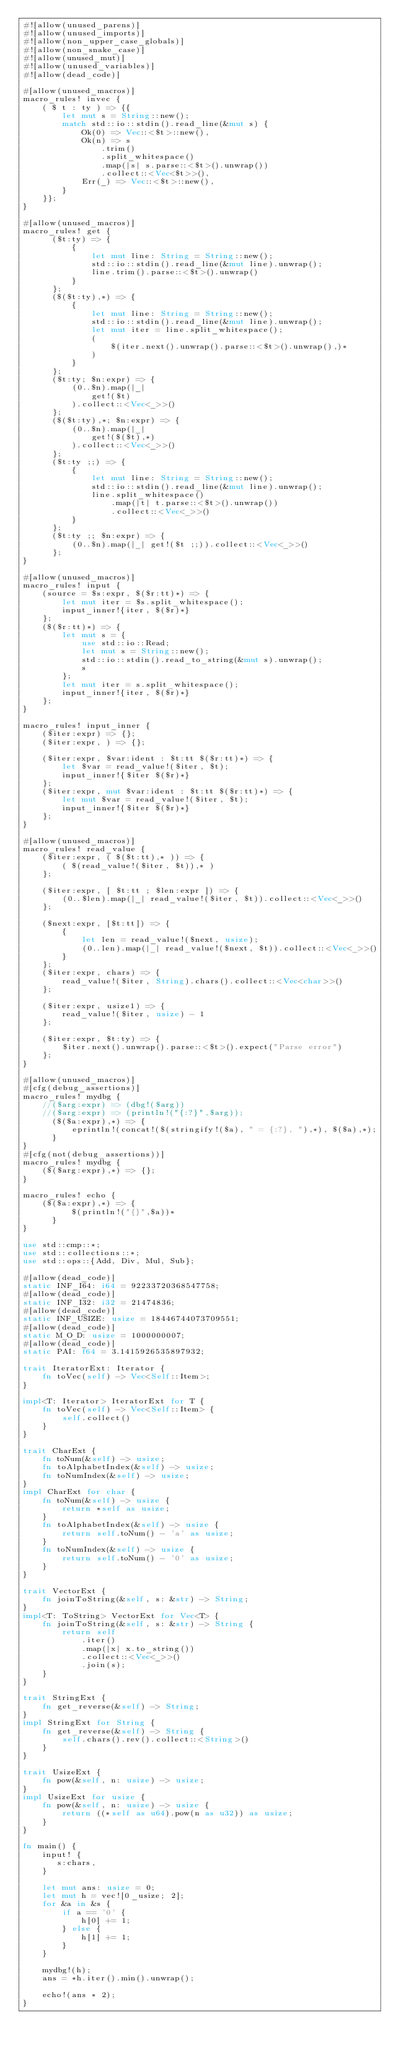Convert code to text. <code><loc_0><loc_0><loc_500><loc_500><_Rust_>#![allow(unused_parens)]
#![allow(unused_imports)]
#![allow(non_upper_case_globals)]
#![allow(non_snake_case)]
#![allow(unused_mut)]
#![allow(unused_variables)]
#![allow(dead_code)]

#[allow(unused_macros)]
macro_rules! invec {
    ( $ t : ty ) => {{
        let mut s = String::new();
        match std::io::stdin().read_line(&mut s) {
            Ok(0) => Vec::<$t>::new(),
            Ok(n) => s
                .trim()
                .split_whitespace()
                .map(|s| s.parse::<$t>().unwrap())
                .collect::<Vec<$t>>(),
            Err(_) => Vec::<$t>::new(),
        }
    }};
}

#[allow(unused_macros)]
macro_rules! get {
      ($t:ty) => {
          {
              let mut line: String = String::new();
              std::io::stdin().read_line(&mut line).unwrap();
              line.trim().parse::<$t>().unwrap()
          }
      };
      ($($t:ty),*) => {
          {
              let mut line: String = String::new();
              std::io::stdin().read_line(&mut line).unwrap();
              let mut iter = line.split_whitespace();
              (
                  $(iter.next().unwrap().parse::<$t>().unwrap(),)*
              )
          }
      };
      ($t:ty; $n:expr) => {
          (0..$n).map(|_|
              get!($t)
          ).collect::<Vec<_>>()
      };
      ($($t:ty),*; $n:expr) => {
          (0..$n).map(|_|
              get!($($t),*)
          ).collect::<Vec<_>>()
      };
      ($t:ty ;;) => {
          {
              let mut line: String = String::new();
              std::io::stdin().read_line(&mut line).unwrap();
              line.split_whitespace()
                  .map(|t| t.parse::<$t>().unwrap())
                  .collect::<Vec<_>>()
          }
      };
      ($t:ty ;; $n:expr) => {
          (0..$n).map(|_| get!($t ;;)).collect::<Vec<_>>()
      };
}

#[allow(unused_macros)]
macro_rules! input {
    (source = $s:expr, $($r:tt)*) => {
        let mut iter = $s.split_whitespace();
        input_inner!{iter, $($r)*}
    };
    ($($r:tt)*) => {
        let mut s = {
            use std::io::Read;
            let mut s = String::new();
            std::io::stdin().read_to_string(&mut s).unwrap();
            s
        };
        let mut iter = s.split_whitespace();
        input_inner!{iter, $($r)*}
    };
}

macro_rules! input_inner {
    ($iter:expr) => {};
    ($iter:expr, ) => {};

    ($iter:expr, $var:ident : $t:tt $($r:tt)*) => {
        let $var = read_value!($iter, $t);
        input_inner!{$iter $($r)*}
    };
    ($iter:expr, mut $var:ident : $t:tt $($r:tt)*) => {
        let mut $var = read_value!($iter, $t);
        input_inner!{$iter $($r)*}
    };
}

#[allow(unused_macros)]
macro_rules! read_value {
    ($iter:expr, ( $($t:tt),* )) => {
        ( $(read_value!($iter, $t)),* )
    };

    ($iter:expr, [ $t:tt ; $len:expr ]) => {
        (0..$len).map(|_| read_value!($iter, $t)).collect::<Vec<_>>()
    };

    ($next:expr, [$t:tt]) => {
        {
            let len = read_value!($next, usize);
            (0..len).map(|_| read_value!($next, $t)).collect::<Vec<_>>()
        }
    };
    ($iter:expr, chars) => {
        read_value!($iter, String).chars().collect::<Vec<char>>()
    };

    ($iter:expr, usize1) => {
        read_value!($iter, usize) - 1
    };

    ($iter:expr, $t:ty) => {
        $iter.next().unwrap().parse::<$t>().expect("Parse error")
    };
}

#[allow(unused_macros)]
#[cfg(debug_assertions)]
macro_rules! mydbg {
    //($arg:expr) => (dbg!($arg))
    //($arg:expr) => (println!("{:?}",$arg));
      ($($a:expr),*) => {
          eprintln!(concat!($(stringify!($a), " = {:?}, "),*), $($a),*);
      }
}
#[cfg(not(debug_assertions))]
macro_rules! mydbg {
    ($($arg:expr),*) => {};
}

macro_rules! echo {
    ($($a:expr),*) => {
          $(println!("{}",$a))*
      }
}

use std::cmp::*;
use std::collections::*;
use std::ops::{Add, Div, Mul, Sub};

#[allow(dead_code)]
static INF_I64: i64 = 92233720368547758;
#[allow(dead_code)]
static INF_I32: i32 = 21474836;
#[allow(dead_code)]
static INF_USIZE: usize = 18446744073709551;
#[allow(dead_code)]
static M_O_D: usize = 1000000007;
#[allow(dead_code)]
static PAI: f64 = 3.1415926535897932;

trait IteratorExt: Iterator {
    fn toVec(self) -> Vec<Self::Item>;
}

impl<T: Iterator> IteratorExt for T {
    fn toVec(self) -> Vec<Self::Item> {
        self.collect()
    }
}

trait CharExt {
    fn toNum(&self) -> usize;
    fn toAlphabetIndex(&self) -> usize;
    fn toNumIndex(&self) -> usize;
}
impl CharExt for char {
    fn toNum(&self) -> usize {
        return *self as usize;
    }
    fn toAlphabetIndex(&self) -> usize {
        return self.toNum() - 'a' as usize;
    }
    fn toNumIndex(&self) -> usize {
        return self.toNum() - '0' as usize;
    }
}

trait VectorExt {
    fn joinToString(&self, s: &str) -> String;
}
impl<T: ToString> VectorExt for Vec<T> {
    fn joinToString(&self, s: &str) -> String {
        return self
            .iter()
            .map(|x| x.to_string())
            .collect::<Vec<_>>()
            .join(s);
    }
}

trait StringExt {
    fn get_reverse(&self) -> String;
}
impl StringExt for String {
    fn get_reverse(&self) -> String {
        self.chars().rev().collect::<String>()
    }
}

trait UsizeExt {
    fn pow(&self, n: usize) -> usize;
}
impl UsizeExt for usize {
    fn pow(&self, n: usize) -> usize {
        return ((*self as u64).pow(n as u32)) as usize;
    }
}

fn main() {
    input! {
       s:chars,
    }

    let mut ans: usize = 0;
    let mut h = vec![0_usize; 2];
    for &a in &s {
        if a == '0' {
            h[0] += 1;
        } else {
            h[1] += 1;
        }
    }

    mydbg!(h);
    ans = *h.iter().min().unwrap();

    echo!(ans * 2);
}
</code> 